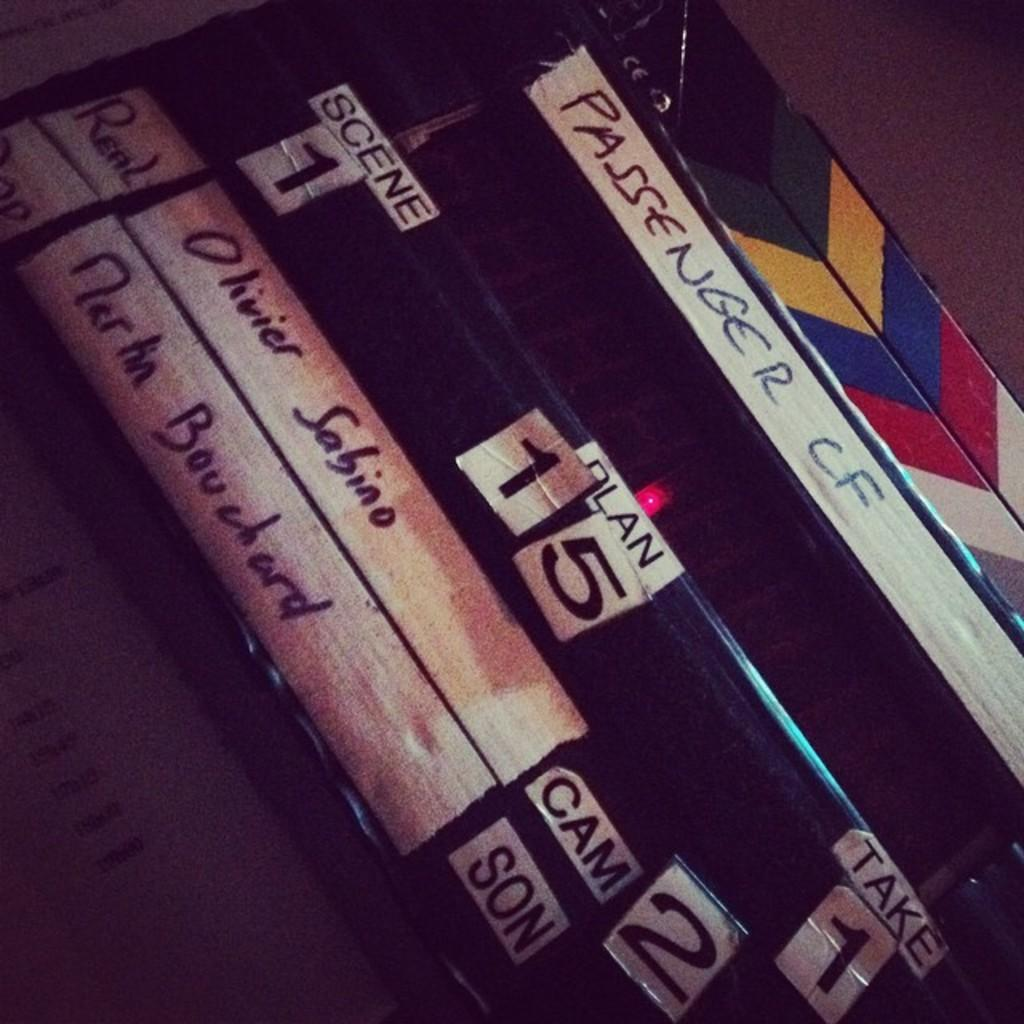<image>
Share a concise interpretation of the image provided. Several cases are labeled with words such as Passenger CF and Plan 15. 